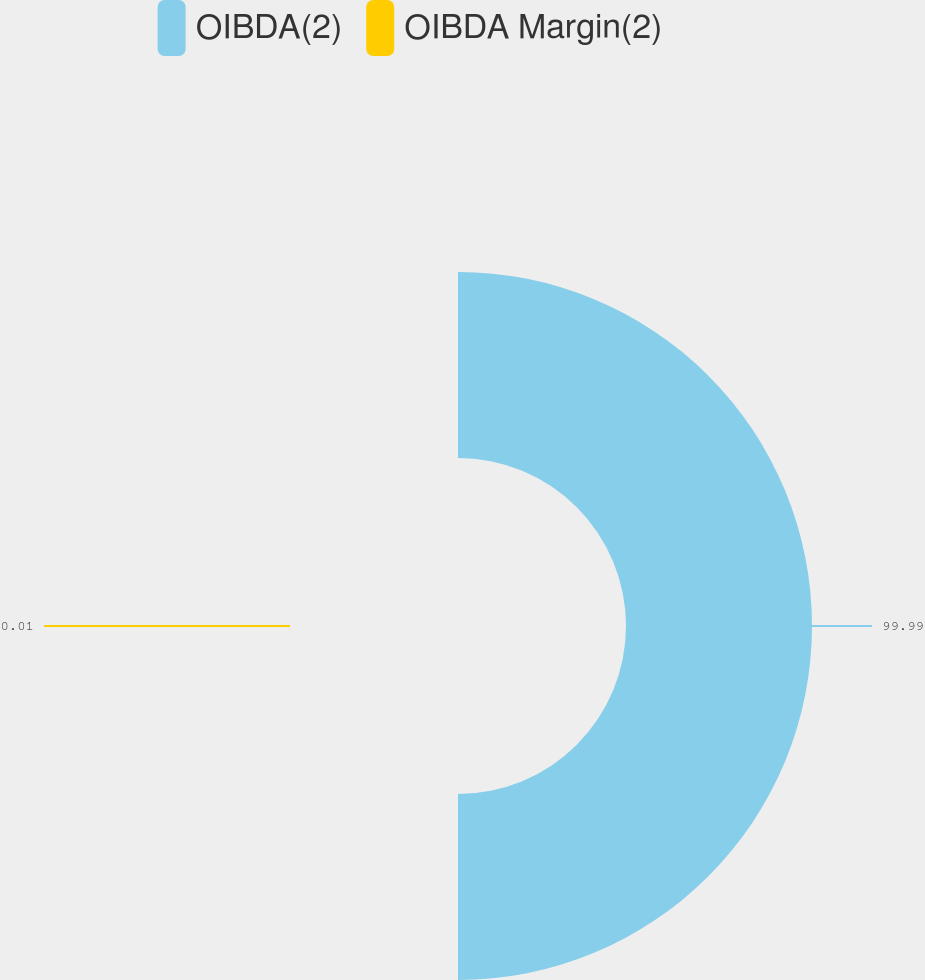<chart> <loc_0><loc_0><loc_500><loc_500><pie_chart><fcel>OIBDA(2)<fcel>OIBDA Margin(2)<nl><fcel>99.99%<fcel>0.01%<nl></chart> 